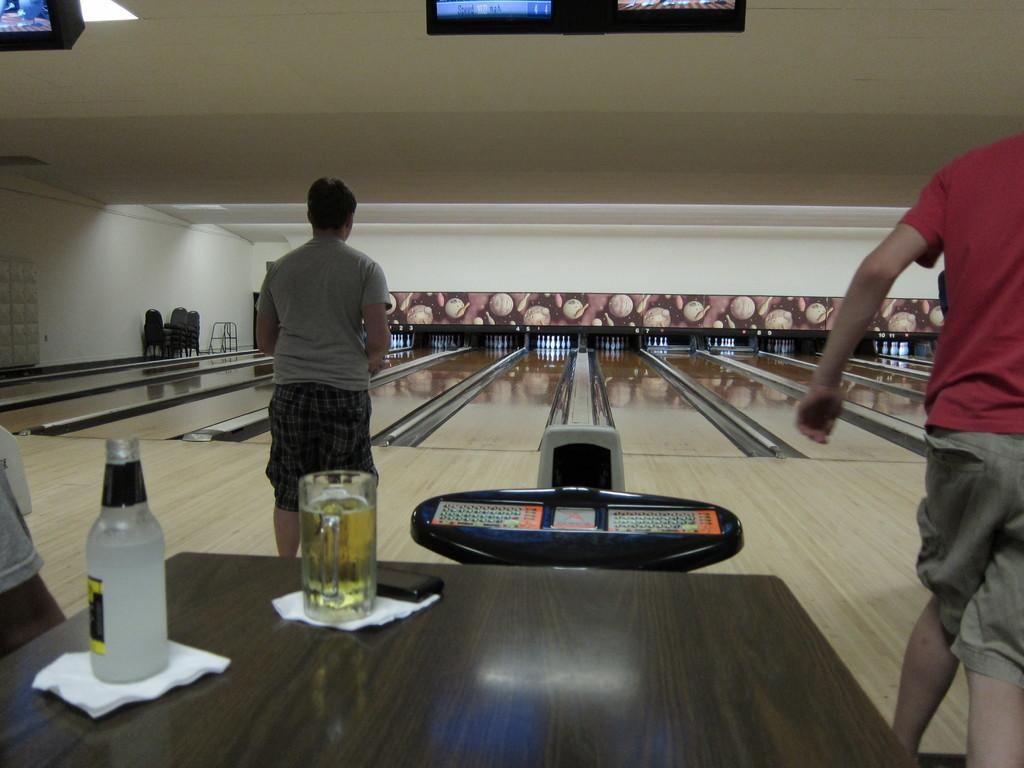What items can be seen on the table in the image? There are tissues, a mobile, a glass of wine, and a bottle on the table in the image. How many people are present in the image? There are three persons in the image. What type of furniture is visible in the image? There are chairs in the image. What additional objects can be seen in the image? There are bowling pins and televisions in the image. Can you describe the car that the fairies are driving in the image? There are no cars or fairies present in the image. 